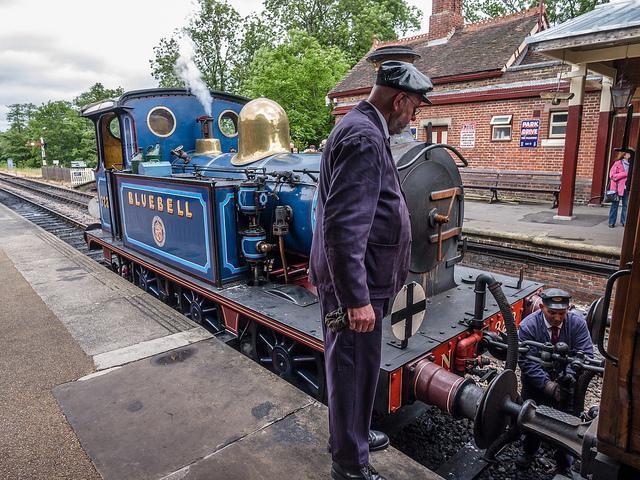How many men are there?
Give a very brief answer. 2. How many people are there?
Give a very brief answer. 2. How many train cars are in the image?
Give a very brief answer. 0. 